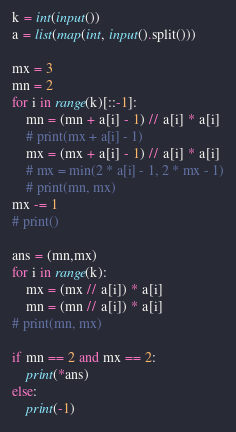Convert code to text. <code><loc_0><loc_0><loc_500><loc_500><_Python_>k = int(input())
a = list(map(int, input().split()))

mx = 3
mn = 2
for i in range(k)[::-1]:
    mn = (mn + a[i] - 1) // a[i] * a[i]
    # print(mx + a[i] - 1)
    mx = (mx + a[i] - 1) // a[i] * a[i]
    # mx = min(2 * a[i] - 1, 2 * mx - 1)
    # print(mn, mx)
mx -= 1
# print()

ans = (mn,mx)
for i in range(k):
    mx = (mx // a[i]) * a[i]
    mn = (mn // a[i]) * a[i]
# print(mn, mx)

if mn == 2 and mx == 2:
    print(*ans)
else:
    print(-1)
</code> 